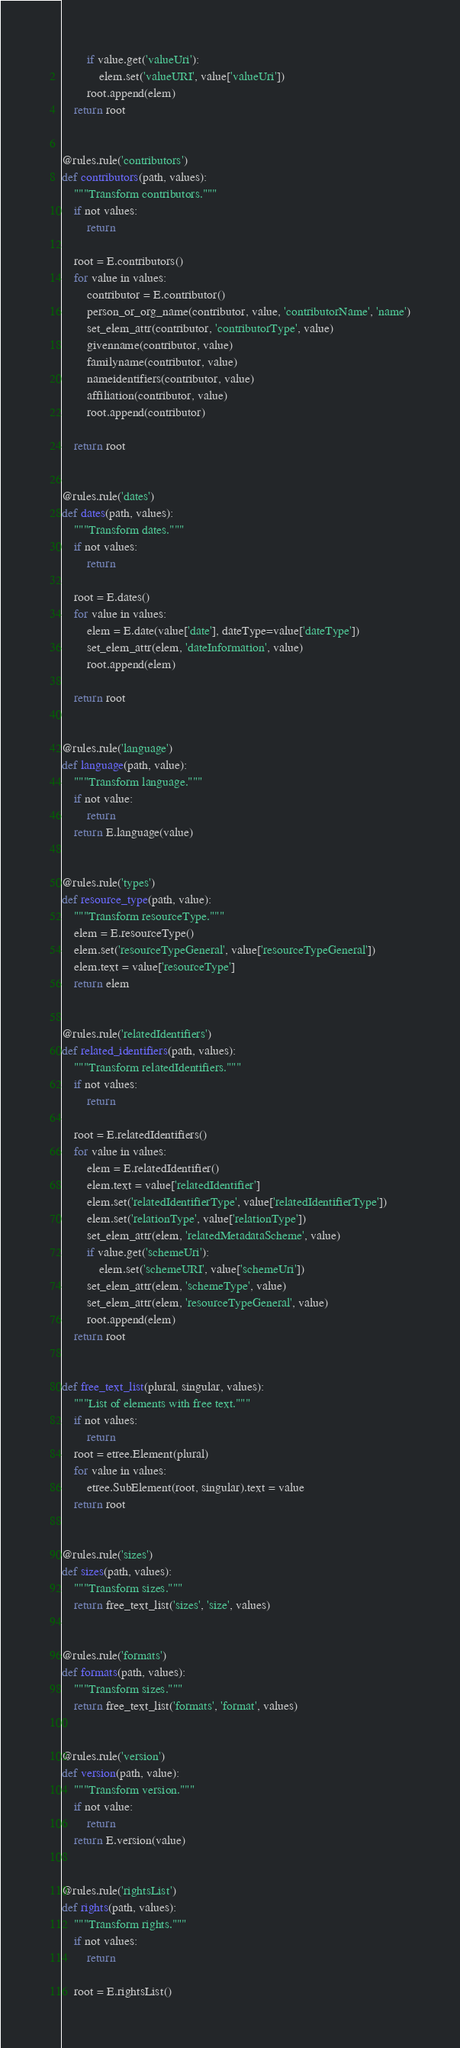Convert code to text. <code><loc_0><loc_0><loc_500><loc_500><_Python_>        if value.get('valueUri'):
            elem.set('valueURI', value['valueUri'])
        root.append(elem)
    return root


@rules.rule('contributors')
def contributors(path, values):
    """Transform contributors."""
    if not values:
        return

    root = E.contributors()
    for value in values:
        contributor = E.contributor()
        person_or_org_name(contributor, value, 'contributorName', 'name')
        set_elem_attr(contributor, 'contributorType', value)
        givenname(contributor, value)
        familyname(contributor, value)
        nameidentifiers(contributor, value)
        affiliation(contributor, value)
        root.append(contributor)

    return root


@rules.rule('dates')
def dates(path, values):
    """Transform dates."""
    if not values:
        return

    root = E.dates()
    for value in values:
        elem = E.date(value['date'], dateType=value['dateType'])
        set_elem_attr(elem, 'dateInformation', value)
        root.append(elem)

    return root


@rules.rule('language')
def language(path, value):
    """Transform language."""
    if not value:
        return
    return E.language(value)


@rules.rule('types')
def resource_type(path, value):
    """Transform resourceType."""
    elem = E.resourceType()
    elem.set('resourceTypeGeneral', value['resourceTypeGeneral'])
    elem.text = value['resourceType']
    return elem


@rules.rule('relatedIdentifiers')
def related_identifiers(path, values):
    """Transform relatedIdentifiers."""
    if not values:
        return

    root = E.relatedIdentifiers()
    for value in values:
        elem = E.relatedIdentifier()
        elem.text = value['relatedIdentifier']
        elem.set('relatedIdentifierType', value['relatedIdentifierType'])
        elem.set('relationType', value['relationType'])
        set_elem_attr(elem, 'relatedMetadataScheme', value)
        if value.get('schemeUri'):
            elem.set('schemeURI', value['schemeUri'])
        set_elem_attr(elem, 'schemeType', value)
        set_elem_attr(elem, 'resourceTypeGeneral', value)
        root.append(elem)
    return root


def free_text_list(plural, singular, values):
    """List of elements with free text."""
    if not values:
        return
    root = etree.Element(plural)
    for value in values:
        etree.SubElement(root, singular).text = value
    return root


@rules.rule('sizes')
def sizes(path, values):
    """Transform sizes."""
    return free_text_list('sizes', 'size', values)


@rules.rule('formats')
def formats(path, values):
    """Transform sizes."""
    return free_text_list('formats', 'format', values)


@rules.rule('version')
def version(path, value):
    """Transform version."""
    if not value:
        return
    return E.version(value)


@rules.rule('rightsList')
def rights(path, values):
    """Transform rights."""
    if not values:
        return

    root = E.rightsList()</code> 